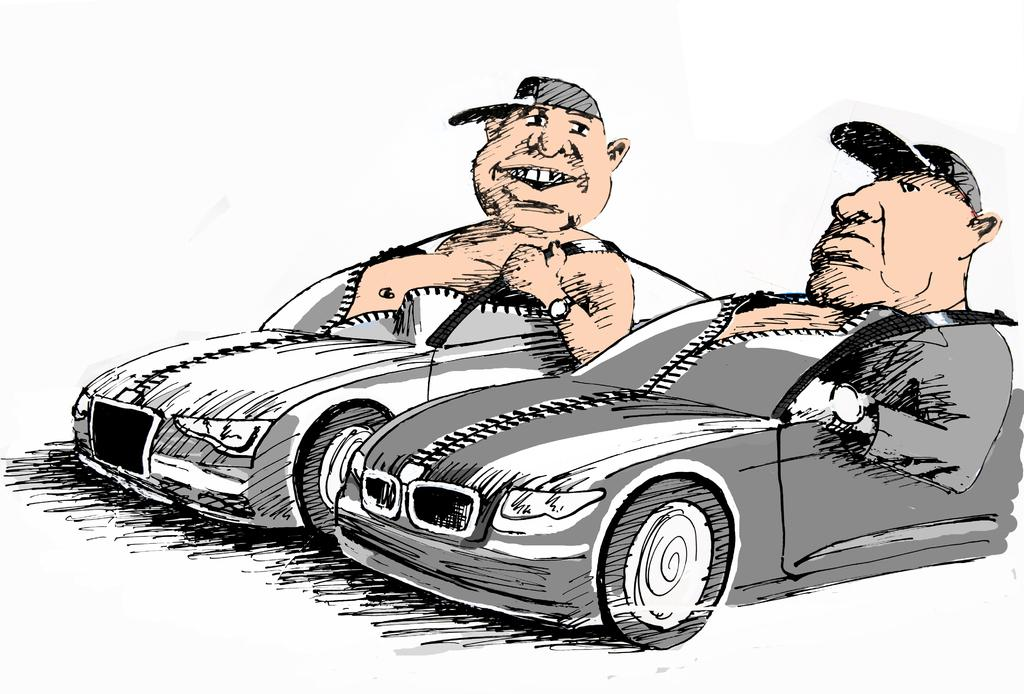What is the main subject of the image? There is a painting in the image. What is depicted in the painting? The painting depicts two men. What are the men doing in the painting? The men are sitting on cars in the painting. What type of chalk is being used by the men in the painting? There is no chalk present in the painting; the men are sitting on cars. What type of sail can be seen in the painting? There is no sail present in the painting; the men are sitting on cars. 